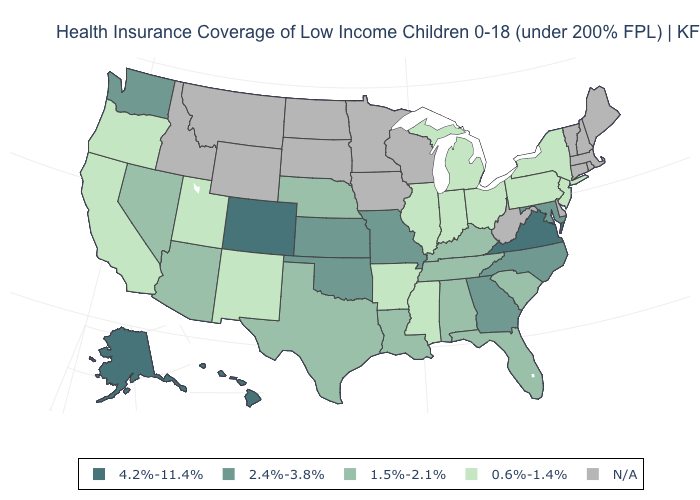Name the states that have a value in the range 0.6%-1.4%?
Keep it brief. Arkansas, California, Illinois, Indiana, Michigan, Mississippi, New Jersey, New Mexico, New York, Ohio, Oregon, Pennsylvania, Utah. What is the value of South Carolina?
Answer briefly. 1.5%-2.1%. What is the lowest value in the USA?
Concise answer only. 0.6%-1.4%. Name the states that have a value in the range 4.2%-11.4%?
Answer briefly. Alaska, Colorado, Hawaii, Virginia. What is the lowest value in the West?
Quick response, please. 0.6%-1.4%. What is the value of Montana?
Be succinct. N/A. Name the states that have a value in the range 1.5%-2.1%?
Keep it brief. Alabama, Arizona, Florida, Kentucky, Louisiana, Nebraska, Nevada, South Carolina, Tennessee, Texas. Is the legend a continuous bar?
Write a very short answer. No. Does the map have missing data?
Short answer required. Yes. Is the legend a continuous bar?
Give a very brief answer. No. Name the states that have a value in the range 0.6%-1.4%?
Quick response, please. Arkansas, California, Illinois, Indiana, Michigan, Mississippi, New Jersey, New Mexico, New York, Ohio, Oregon, Pennsylvania, Utah. Name the states that have a value in the range 4.2%-11.4%?
Keep it brief. Alaska, Colorado, Hawaii, Virginia. What is the highest value in the South ?
Keep it brief. 4.2%-11.4%. Does the map have missing data?
Write a very short answer. Yes. Name the states that have a value in the range 2.4%-3.8%?
Answer briefly. Georgia, Kansas, Maryland, Missouri, North Carolina, Oklahoma, Washington. 